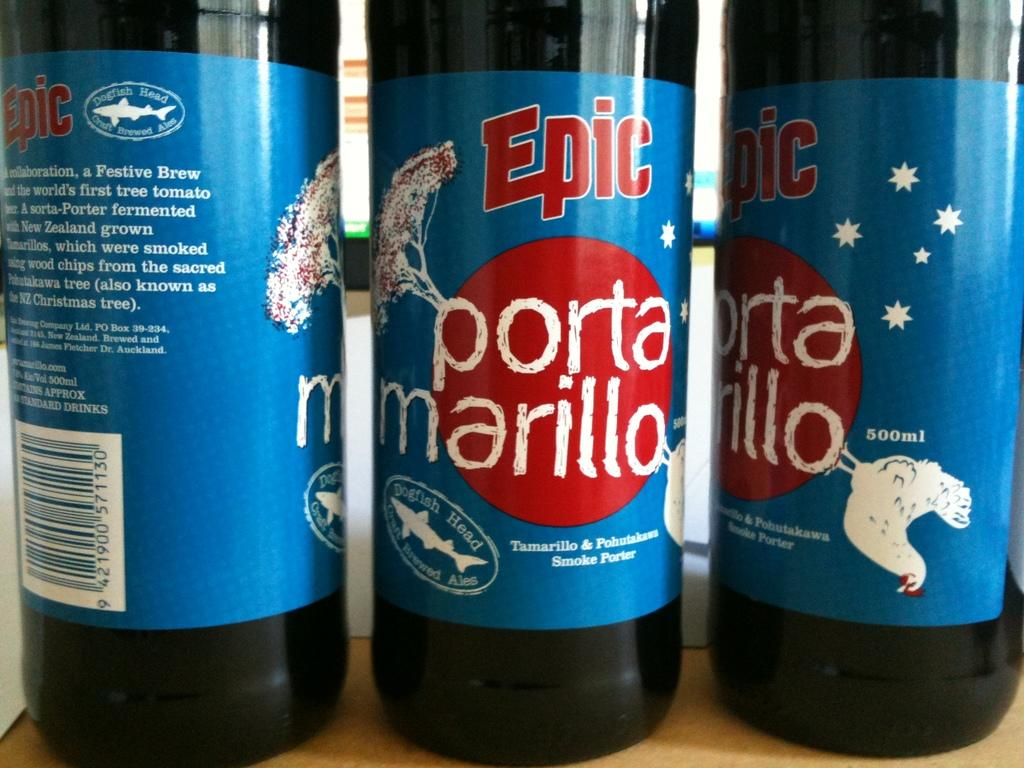<image>
Share a concise interpretation of the image provided. Three bottles of Epic porta marillo are next to each other on a wooden surface. 